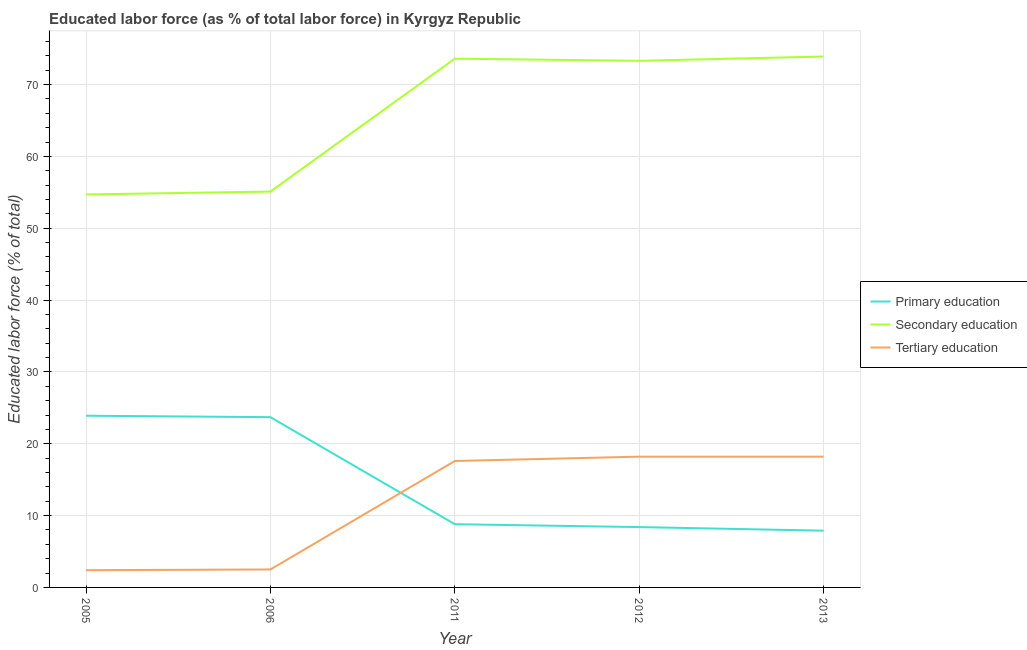How many different coloured lines are there?
Your response must be concise. 3. Does the line corresponding to percentage of labor force who received secondary education intersect with the line corresponding to percentage of labor force who received tertiary education?
Provide a succinct answer. No. What is the percentage of labor force who received primary education in 2006?
Make the answer very short. 23.7. Across all years, what is the maximum percentage of labor force who received secondary education?
Give a very brief answer. 73.9. Across all years, what is the minimum percentage of labor force who received tertiary education?
Give a very brief answer. 2.4. In which year was the percentage of labor force who received tertiary education maximum?
Your answer should be compact. 2012. In which year was the percentage of labor force who received primary education minimum?
Provide a short and direct response. 2013. What is the total percentage of labor force who received tertiary education in the graph?
Your answer should be very brief. 58.9. What is the difference between the percentage of labor force who received secondary education in 2005 and that in 2013?
Offer a terse response. -19.2. What is the difference between the percentage of labor force who received tertiary education in 2012 and the percentage of labor force who received secondary education in 2011?
Provide a short and direct response. -55.4. What is the average percentage of labor force who received tertiary education per year?
Make the answer very short. 11.78. In the year 2012, what is the difference between the percentage of labor force who received secondary education and percentage of labor force who received tertiary education?
Offer a very short reply. 55.1. What is the ratio of the percentage of labor force who received tertiary education in 2006 to that in 2011?
Make the answer very short. 0.14. Is the difference between the percentage of labor force who received primary education in 2006 and 2013 greater than the difference between the percentage of labor force who received secondary education in 2006 and 2013?
Offer a terse response. Yes. What is the difference between the highest and the lowest percentage of labor force who received tertiary education?
Your answer should be very brief. 15.8. Is the sum of the percentage of labor force who received secondary education in 2005 and 2006 greater than the maximum percentage of labor force who received tertiary education across all years?
Offer a terse response. Yes. Is it the case that in every year, the sum of the percentage of labor force who received primary education and percentage of labor force who received secondary education is greater than the percentage of labor force who received tertiary education?
Give a very brief answer. Yes. How many lines are there?
Ensure brevity in your answer.  3. What is the difference between two consecutive major ticks on the Y-axis?
Provide a succinct answer. 10. Are the values on the major ticks of Y-axis written in scientific E-notation?
Offer a terse response. No. How many legend labels are there?
Give a very brief answer. 3. What is the title of the graph?
Your answer should be very brief. Educated labor force (as % of total labor force) in Kyrgyz Republic. What is the label or title of the Y-axis?
Your response must be concise. Educated labor force (% of total). What is the Educated labor force (% of total) in Primary education in 2005?
Ensure brevity in your answer.  23.9. What is the Educated labor force (% of total) of Secondary education in 2005?
Offer a very short reply. 54.7. What is the Educated labor force (% of total) in Tertiary education in 2005?
Provide a short and direct response. 2.4. What is the Educated labor force (% of total) of Primary education in 2006?
Give a very brief answer. 23.7. What is the Educated labor force (% of total) of Secondary education in 2006?
Offer a terse response. 55.1. What is the Educated labor force (% of total) in Primary education in 2011?
Your response must be concise. 8.8. What is the Educated labor force (% of total) of Secondary education in 2011?
Offer a terse response. 73.6. What is the Educated labor force (% of total) in Tertiary education in 2011?
Make the answer very short. 17.6. What is the Educated labor force (% of total) in Primary education in 2012?
Give a very brief answer. 8.4. What is the Educated labor force (% of total) in Secondary education in 2012?
Your answer should be very brief. 73.3. What is the Educated labor force (% of total) of Tertiary education in 2012?
Your answer should be compact. 18.2. What is the Educated labor force (% of total) in Primary education in 2013?
Keep it short and to the point. 7.9. What is the Educated labor force (% of total) in Secondary education in 2013?
Your answer should be compact. 73.9. What is the Educated labor force (% of total) of Tertiary education in 2013?
Give a very brief answer. 18.2. Across all years, what is the maximum Educated labor force (% of total) in Primary education?
Make the answer very short. 23.9. Across all years, what is the maximum Educated labor force (% of total) of Secondary education?
Ensure brevity in your answer.  73.9. Across all years, what is the maximum Educated labor force (% of total) in Tertiary education?
Provide a succinct answer. 18.2. Across all years, what is the minimum Educated labor force (% of total) of Primary education?
Your answer should be very brief. 7.9. Across all years, what is the minimum Educated labor force (% of total) in Secondary education?
Your answer should be very brief. 54.7. Across all years, what is the minimum Educated labor force (% of total) in Tertiary education?
Offer a terse response. 2.4. What is the total Educated labor force (% of total) in Primary education in the graph?
Your response must be concise. 72.7. What is the total Educated labor force (% of total) of Secondary education in the graph?
Provide a short and direct response. 330.6. What is the total Educated labor force (% of total) in Tertiary education in the graph?
Provide a succinct answer. 58.9. What is the difference between the Educated labor force (% of total) in Secondary education in 2005 and that in 2006?
Ensure brevity in your answer.  -0.4. What is the difference between the Educated labor force (% of total) of Secondary education in 2005 and that in 2011?
Provide a succinct answer. -18.9. What is the difference between the Educated labor force (% of total) of Tertiary education in 2005 and that in 2011?
Your answer should be very brief. -15.2. What is the difference between the Educated labor force (% of total) of Secondary education in 2005 and that in 2012?
Keep it short and to the point. -18.6. What is the difference between the Educated labor force (% of total) in Tertiary education in 2005 and that in 2012?
Your answer should be compact. -15.8. What is the difference between the Educated labor force (% of total) in Primary education in 2005 and that in 2013?
Keep it short and to the point. 16. What is the difference between the Educated labor force (% of total) in Secondary education in 2005 and that in 2013?
Your response must be concise. -19.2. What is the difference between the Educated labor force (% of total) in Tertiary education in 2005 and that in 2013?
Your response must be concise. -15.8. What is the difference between the Educated labor force (% of total) of Primary education in 2006 and that in 2011?
Your answer should be very brief. 14.9. What is the difference between the Educated labor force (% of total) of Secondary education in 2006 and that in 2011?
Keep it short and to the point. -18.5. What is the difference between the Educated labor force (% of total) in Tertiary education in 2006 and that in 2011?
Give a very brief answer. -15.1. What is the difference between the Educated labor force (% of total) in Secondary education in 2006 and that in 2012?
Give a very brief answer. -18.2. What is the difference between the Educated labor force (% of total) in Tertiary education in 2006 and that in 2012?
Ensure brevity in your answer.  -15.7. What is the difference between the Educated labor force (% of total) of Secondary education in 2006 and that in 2013?
Ensure brevity in your answer.  -18.8. What is the difference between the Educated labor force (% of total) in Tertiary education in 2006 and that in 2013?
Provide a short and direct response. -15.7. What is the difference between the Educated labor force (% of total) in Secondary education in 2011 and that in 2012?
Your answer should be compact. 0.3. What is the difference between the Educated labor force (% of total) of Primary education in 2011 and that in 2013?
Give a very brief answer. 0.9. What is the difference between the Educated labor force (% of total) in Primary education in 2012 and that in 2013?
Offer a terse response. 0.5. What is the difference between the Educated labor force (% of total) in Tertiary education in 2012 and that in 2013?
Keep it short and to the point. 0. What is the difference between the Educated labor force (% of total) in Primary education in 2005 and the Educated labor force (% of total) in Secondary education in 2006?
Make the answer very short. -31.2. What is the difference between the Educated labor force (% of total) in Primary education in 2005 and the Educated labor force (% of total) in Tertiary education in 2006?
Give a very brief answer. 21.4. What is the difference between the Educated labor force (% of total) of Secondary education in 2005 and the Educated labor force (% of total) of Tertiary education in 2006?
Your answer should be very brief. 52.2. What is the difference between the Educated labor force (% of total) of Primary education in 2005 and the Educated labor force (% of total) of Secondary education in 2011?
Your answer should be very brief. -49.7. What is the difference between the Educated labor force (% of total) of Secondary education in 2005 and the Educated labor force (% of total) of Tertiary education in 2011?
Keep it short and to the point. 37.1. What is the difference between the Educated labor force (% of total) of Primary education in 2005 and the Educated labor force (% of total) of Secondary education in 2012?
Ensure brevity in your answer.  -49.4. What is the difference between the Educated labor force (% of total) of Secondary education in 2005 and the Educated labor force (% of total) of Tertiary education in 2012?
Keep it short and to the point. 36.5. What is the difference between the Educated labor force (% of total) of Primary education in 2005 and the Educated labor force (% of total) of Tertiary education in 2013?
Provide a succinct answer. 5.7. What is the difference between the Educated labor force (% of total) in Secondary education in 2005 and the Educated labor force (% of total) in Tertiary education in 2013?
Make the answer very short. 36.5. What is the difference between the Educated labor force (% of total) in Primary education in 2006 and the Educated labor force (% of total) in Secondary education in 2011?
Keep it short and to the point. -49.9. What is the difference between the Educated labor force (% of total) of Primary education in 2006 and the Educated labor force (% of total) of Tertiary education in 2011?
Make the answer very short. 6.1. What is the difference between the Educated labor force (% of total) in Secondary education in 2006 and the Educated labor force (% of total) in Tertiary education in 2011?
Your answer should be very brief. 37.5. What is the difference between the Educated labor force (% of total) in Primary education in 2006 and the Educated labor force (% of total) in Secondary education in 2012?
Ensure brevity in your answer.  -49.6. What is the difference between the Educated labor force (% of total) in Secondary education in 2006 and the Educated labor force (% of total) in Tertiary education in 2012?
Provide a succinct answer. 36.9. What is the difference between the Educated labor force (% of total) of Primary education in 2006 and the Educated labor force (% of total) of Secondary education in 2013?
Offer a very short reply. -50.2. What is the difference between the Educated labor force (% of total) in Primary education in 2006 and the Educated labor force (% of total) in Tertiary education in 2013?
Offer a terse response. 5.5. What is the difference between the Educated labor force (% of total) in Secondary education in 2006 and the Educated labor force (% of total) in Tertiary education in 2013?
Your answer should be compact. 36.9. What is the difference between the Educated labor force (% of total) of Primary education in 2011 and the Educated labor force (% of total) of Secondary education in 2012?
Offer a very short reply. -64.5. What is the difference between the Educated labor force (% of total) in Secondary education in 2011 and the Educated labor force (% of total) in Tertiary education in 2012?
Make the answer very short. 55.4. What is the difference between the Educated labor force (% of total) in Primary education in 2011 and the Educated labor force (% of total) in Secondary education in 2013?
Provide a succinct answer. -65.1. What is the difference between the Educated labor force (% of total) of Primary education in 2011 and the Educated labor force (% of total) of Tertiary education in 2013?
Your response must be concise. -9.4. What is the difference between the Educated labor force (% of total) in Secondary education in 2011 and the Educated labor force (% of total) in Tertiary education in 2013?
Provide a short and direct response. 55.4. What is the difference between the Educated labor force (% of total) in Primary education in 2012 and the Educated labor force (% of total) in Secondary education in 2013?
Provide a succinct answer. -65.5. What is the difference between the Educated labor force (% of total) of Primary education in 2012 and the Educated labor force (% of total) of Tertiary education in 2013?
Offer a very short reply. -9.8. What is the difference between the Educated labor force (% of total) of Secondary education in 2012 and the Educated labor force (% of total) of Tertiary education in 2013?
Your response must be concise. 55.1. What is the average Educated labor force (% of total) of Primary education per year?
Provide a short and direct response. 14.54. What is the average Educated labor force (% of total) of Secondary education per year?
Provide a succinct answer. 66.12. What is the average Educated labor force (% of total) in Tertiary education per year?
Provide a succinct answer. 11.78. In the year 2005, what is the difference between the Educated labor force (% of total) in Primary education and Educated labor force (% of total) in Secondary education?
Provide a succinct answer. -30.8. In the year 2005, what is the difference between the Educated labor force (% of total) in Secondary education and Educated labor force (% of total) in Tertiary education?
Provide a short and direct response. 52.3. In the year 2006, what is the difference between the Educated labor force (% of total) in Primary education and Educated labor force (% of total) in Secondary education?
Offer a very short reply. -31.4. In the year 2006, what is the difference between the Educated labor force (% of total) of Primary education and Educated labor force (% of total) of Tertiary education?
Your answer should be very brief. 21.2. In the year 2006, what is the difference between the Educated labor force (% of total) in Secondary education and Educated labor force (% of total) in Tertiary education?
Offer a terse response. 52.6. In the year 2011, what is the difference between the Educated labor force (% of total) of Primary education and Educated labor force (% of total) of Secondary education?
Ensure brevity in your answer.  -64.8. In the year 2012, what is the difference between the Educated labor force (% of total) of Primary education and Educated labor force (% of total) of Secondary education?
Your response must be concise. -64.9. In the year 2012, what is the difference between the Educated labor force (% of total) of Secondary education and Educated labor force (% of total) of Tertiary education?
Keep it short and to the point. 55.1. In the year 2013, what is the difference between the Educated labor force (% of total) in Primary education and Educated labor force (% of total) in Secondary education?
Your response must be concise. -66. In the year 2013, what is the difference between the Educated labor force (% of total) of Primary education and Educated labor force (% of total) of Tertiary education?
Offer a terse response. -10.3. In the year 2013, what is the difference between the Educated labor force (% of total) in Secondary education and Educated labor force (% of total) in Tertiary education?
Offer a terse response. 55.7. What is the ratio of the Educated labor force (% of total) of Primary education in 2005 to that in 2006?
Offer a very short reply. 1.01. What is the ratio of the Educated labor force (% of total) of Secondary education in 2005 to that in 2006?
Your response must be concise. 0.99. What is the ratio of the Educated labor force (% of total) of Primary education in 2005 to that in 2011?
Your answer should be compact. 2.72. What is the ratio of the Educated labor force (% of total) of Secondary education in 2005 to that in 2011?
Make the answer very short. 0.74. What is the ratio of the Educated labor force (% of total) of Tertiary education in 2005 to that in 2011?
Provide a short and direct response. 0.14. What is the ratio of the Educated labor force (% of total) of Primary education in 2005 to that in 2012?
Provide a short and direct response. 2.85. What is the ratio of the Educated labor force (% of total) in Secondary education in 2005 to that in 2012?
Give a very brief answer. 0.75. What is the ratio of the Educated labor force (% of total) in Tertiary education in 2005 to that in 2012?
Provide a succinct answer. 0.13. What is the ratio of the Educated labor force (% of total) in Primary education in 2005 to that in 2013?
Your answer should be compact. 3.03. What is the ratio of the Educated labor force (% of total) in Secondary education in 2005 to that in 2013?
Offer a terse response. 0.74. What is the ratio of the Educated labor force (% of total) of Tertiary education in 2005 to that in 2013?
Make the answer very short. 0.13. What is the ratio of the Educated labor force (% of total) of Primary education in 2006 to that in 2011?
Keep it short and to the point. 2.69. What is the ratio of the Educated labor force (% of total) of Secondary education in 2006 to that in 2011?
Provide a succinct answer. 0.75. What is the ratio of the Educated labor force (% of total) of Tertiary education in 2006 to that in 2011?
Your answer should be very brief. 0.14. What is the ratio of the Educated labor force (% of total) of Primary education in 2006 to that in 2012?
Your answer should be very brief. 2.82. What is the ratio of the Educated labor force (% of total) in Secondary education in 2006 to that in 2012?
Your response must be concise. 0.75. What is the ratio of the Educated labor force (% of total) in Tertiary education in 2006 to that in 2012?
Ensure brevity in your answer.  0.14. What is the ratio of the Educated labor force (% of total) of Secondary education in 2006 to that in 2013?
Offer a very short reply. 0.75. What is the ratio of the Educated labor force (% of total) of Tertiary education in 2006 to that in 2013?
Provide a succinct answer. 0.14. What is the ratio of the Educated labor force (% of total) of Primary education in 2011 to that in 2012?
Provide a short and direct response. 1.05. What is the ratio of the Educated labor force (% of total) of Primary education in 2011 to that in 2013?
Ensure brevity in your answer.  1.11. What is the ratio of the Educated labor force (% of total) of Secondary education in 2011 to that in 2013?
Your response must be concise. 1. What is the ratio of the Educated labor force (% of total) of Primary education in 2012 to that in 2013?
Give a very brief answer. 1.06. What is the ratio of the Educated labor force (% of total) of Tertiary education in 2012 to that in 2013?
Provide a short and direct response. 1. What is the difference between the highest and the second highest Educated labor force (% of total) of Tertiary education?
Make the answer very short. 0. What is the difference between the highest and the lowest Educated labor force (% of total) in Primary education?
Ensure brevity in your answer.  16. What is the difference between the highest and the lowest Educated labor force (% of total) of Secondary education?
Provide a succinct answer. 19.2. 